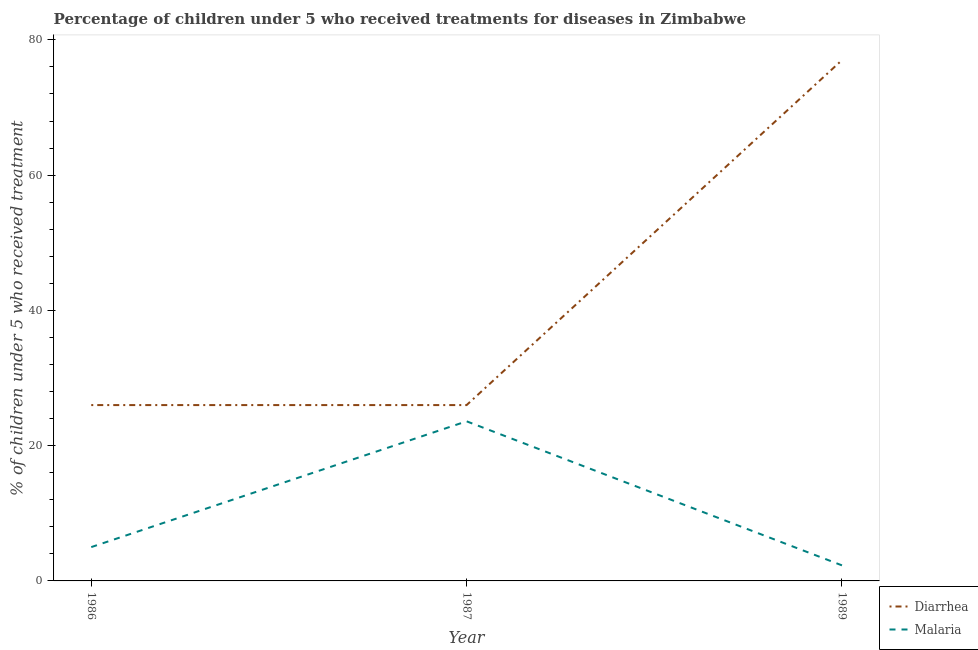Does the line corresponding to percentage of children who received treatment for malaria intersect with the line corresponding to percentage of children who received treatment for diarrhoea?
Your answer should be compact. No. Is the number of lines equal to the number of legend labels?
Offer a terse response. Yes. What is the percentage of children who received treatment for diarrhoea in 1987?
Ensure brevity in your answer.  26. Across all years, what is the maximum percentage of children who received treatment for malaria?
Your answer should be compact. 23.6. Across all years, what is the minimum percentage of children who received treatment for malaria?
Your answer should be very brief. 2.3. What is the total percentage of children who received treatment for malaria in the graph?
Your answer should be compact. 30.9. What is the average percentage of children who received treatment for malaria per year?
Give a very brief answer. 10.3. In the year 1987, what is the difference between the percentage of children who received treatment for malaria and percentage of children who received treatment for diarrhoea?
Provide a succinct answer. -2.4. Is the percentage of children who received treatment for diarrhoea in 1986 less than that in 1989?
Your answer should be very brief. Yes. Is the difference between the percentage of children who received treatment for diarrhoea in 1986 and 1989 greater than the difference between the percentage of children who received treatment for malaria in 1986 and 1989?
Your answer should be compact. No. What is the difference between the highest and the second highest percentage of children who received treatment for malaria?
Provide a succinct answer. 18.6. What is the difference between the highest and the lowest percentage of children who received treatment for diarrhoea?
Ensure brevity in your answer.  51. Is the sum of the percentage of children who received treatment for diarrhoea in 1987 and 1989 greater than the maximum percentage of children who received treatment for malaria across all years?
Give a very brief answer. Yes. Is the percentage of children who received treatment for diarrhoea strictly less than the percentage of children who received treatment for malaria over the years?
Your response must be concise. No. How many years are there in the graph?
Your response must be concise. 3. Are the values on the major ticks of Y-axis written in scientific E-notation?
Make the answer very short. No. Does the graph contain any zero values?
Make the answer very short. No. Does the graph contain grids?
Offer a terse response. No. Where does the legend appear in the graph?
Your answer should be compact. Bottom right. How many legend labels are there?
Provide a short and direct response. 2. What is the title of the graph?
Keep it short and to the point. Percentage of children under 5 who received treatments for diseases in Zimbabwe. Does "Automatic Teller Machines" appear as one of the legend labels in the graph?
Offer a very short reply. No. What is the label or title of the X-axis?
Offer a very short reply. Year. What is the label or title of the Y-axis?
Your answer should be very brief. % of children under 5 who received treatment. What is the % of children under 5 who received treatment in Malaria in 1987?
Keep it short and to the point. 23.6. What is the % of children under 5 who received treatment of Malaria in 1989?
Your answer should be compact. 2.3. Across all years, what is the maximum % of children under 5 who received treatment in Malaria?
Offer a very short reply. 23.6. What is the total % of children under 5 who received treatment of Diarrhea in the graph?
Keep it short and to the point. 129. What is the total % of children under 5 who received treatment in Malaria in the graph?
Your answer should be very brief. 30.9. What is the difference between the % of children under 5 who received treatment of Malaria in 1986 and that in 1987?
Your response must be concise. -18.6. What is the difference between the % of children under 5 who received treatment of Diarrhea in 1986 and that in 1989?
Your answer should be very brief. -51. What is the difference between the % of children under 5 who received treatment in Malaria in 1986 and that in 1989?
Ensure brevity in your answer.  2.7. What is the difference between the % of children under 5 who received treatment in Diarrhea in 1987 and that in 1989?
Offer a very short reply. -51. What is the difference between the % of children under 5 who received treatment of Malaria in 1987 and that in 1989?
Your answer should be very brief. 21.3. What is the difference between the % of children under 5 who received treatment of Diarrhea in 1986 and the % of children under 5 who received treatment of Malaria in 1987?
Give a very brief answer. 2.4. What is the difference between the % of children under 5 who received treatment of Diarrhea in 1986 and the % of children under 5 who received treatment of Malaria in 1989?
Offer a very short reply. 23.7. What is the difference between the % of children under 5 who received treatment in Diarrhea in 1987 and the % of children under 5 who received treatment in Malaria in 1989?
Your answer should be very brief. 23.7. In the year 1989, what is the difference between the % of children under 5 who received treatment in Diarrhea and % of children under 5 who received treatment in Malaria?
Your answer should be compact. 74.7. What is the ratio of the % of children under 5 who received treatment of Malaria in 1986 to that in 1987?
Ensure brevity in your answer.  0.21. What is the ratio of the % of children under 5 who received treatment in Diarrhea in 1986 to that in 1989?
Offer a very short reply. 0.34. What is the ratio of the % of children under 5 who received treatment of Malaria in 1986 to that in 1989?
Your answer should be compact. 2.17. What is the ratio of the % of children under 5 who received treatment of Diarrhea in 1987 to that in 1989?
Your answer should be very brief. 0.34. What is the ratio of the % of children under 5 who received treatment in Malaria in 1987 to that in 1989?
Provide a succinct answer. 10.26. What is the difference between the highest and the second highest % of children under 5 who received treatment in Malaria?
Make the answer very short. 18.6. What is the difference between the highest and the lowest % of children under 5 who received treatment in Diarrhea?
Your response must be concise. 51. What is the difference between the highest and the lowest % of children under 5 who received treatment of Malaria?
Offer a terse response. 21.3. 